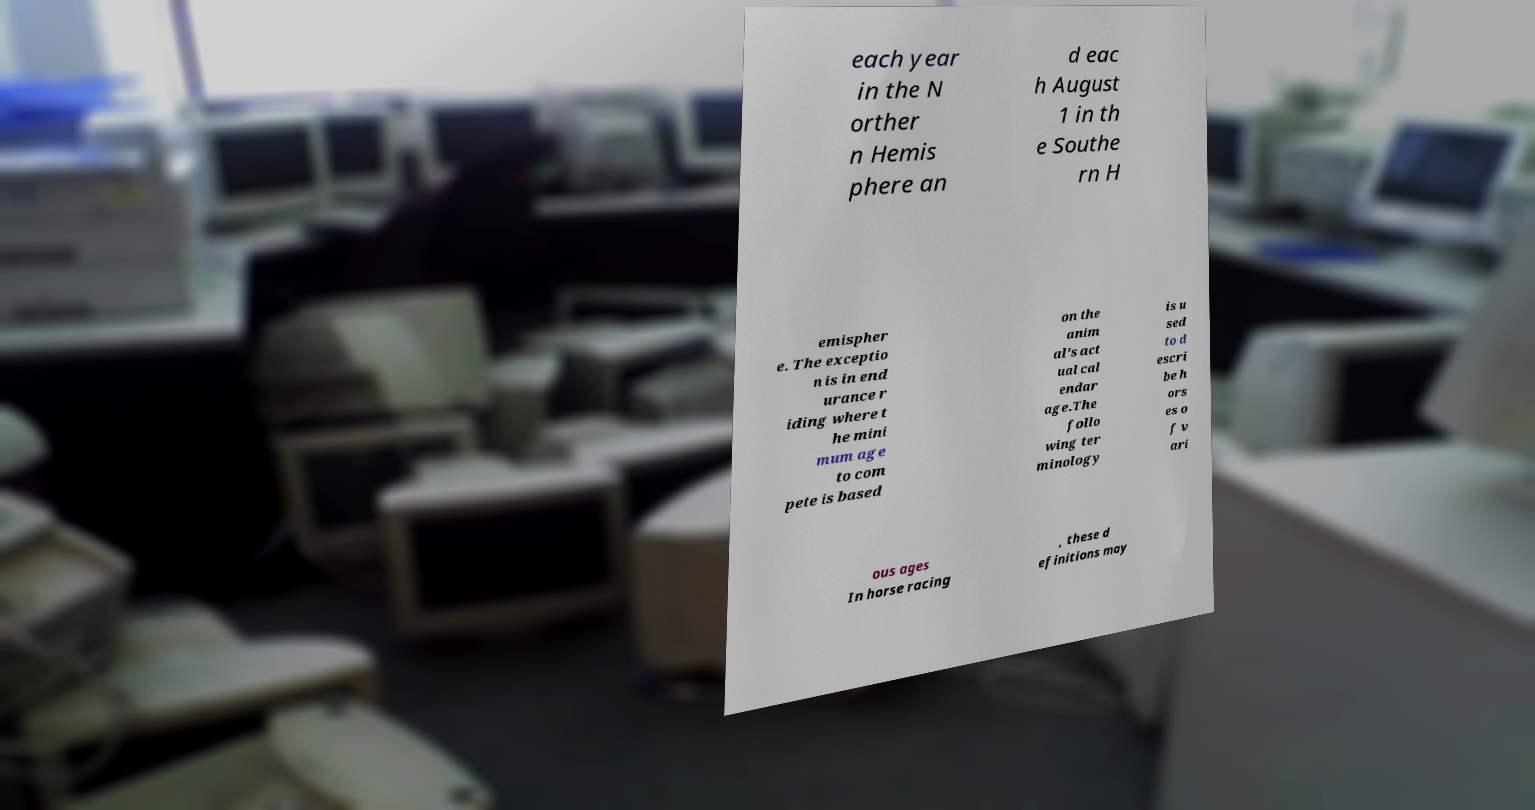Can you read and provide the text displayed in the image?This photo seems to have some interesting text. Can you extract and type it out for me? each year in the N orther n Hemis phere an d eac h August 1 in th e Southe rn H emispher e. The exceptio n is in end urance r iding where t he mini mum age to com pete is based on the anim al's act ual cal endar age.The follo wing ter minology is u sed to d escri be h ors es o f v ari ous ages In horse racing , these d efinitions may 